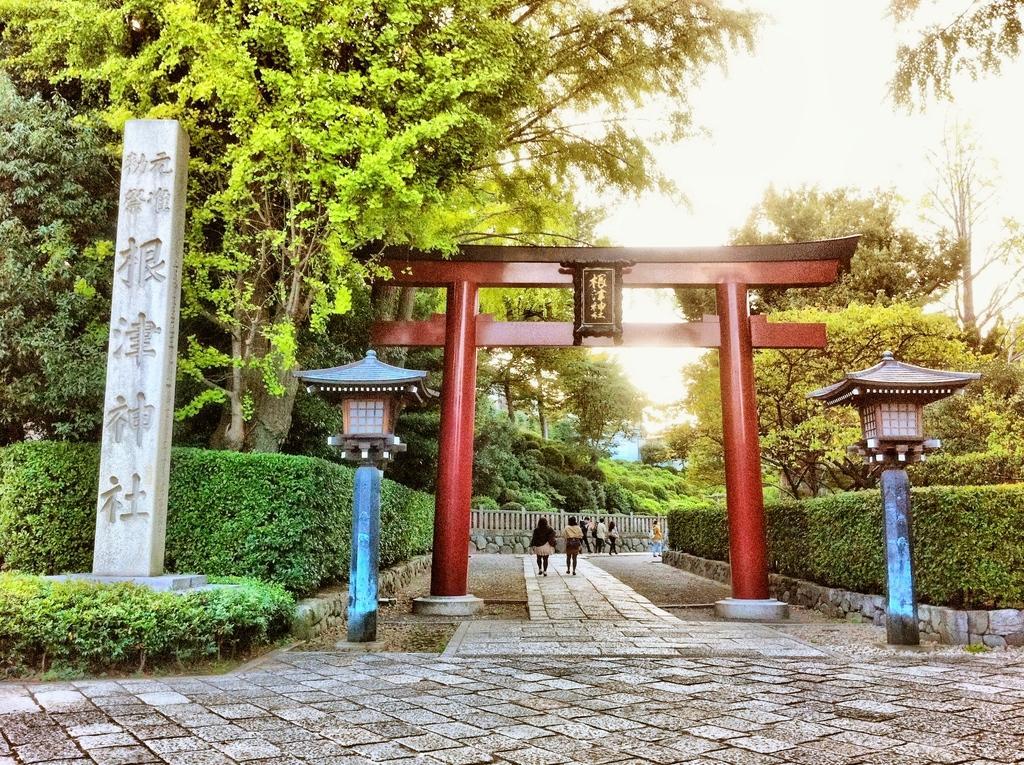In one or two sentences, can you explain what this image depicts? In this picture there are trees on the right and left side of the image, there are trees on the right and left side of the image, there are lamps in the image. 